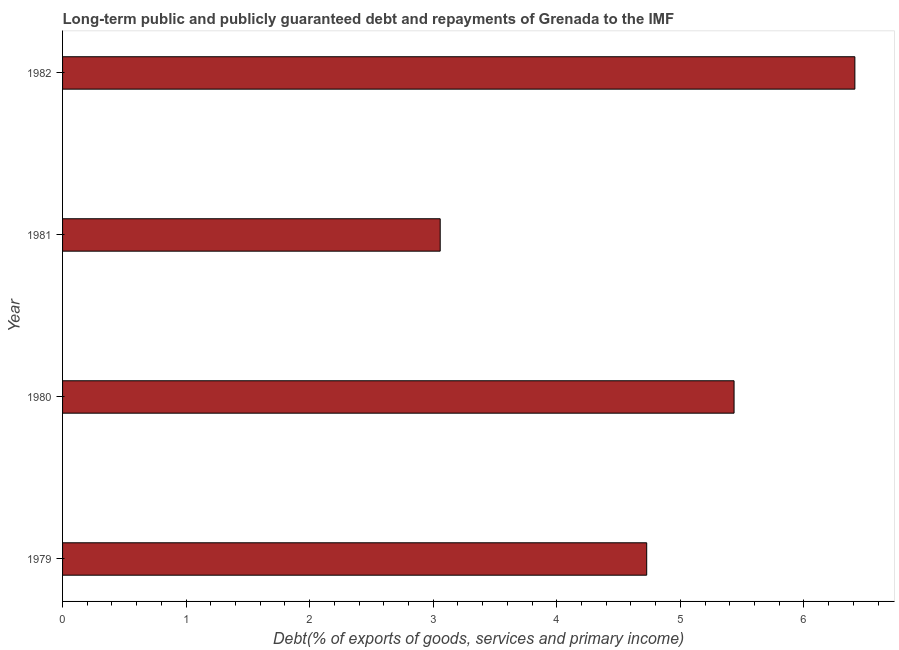Does the graph contain any zero values?
Your answer should be compact. No. What is the title of the graph?
Your answer should be very brief. Long-term public and publicly guaranteed debt and repayments of Grenada to the IMF. What is the label or title of the X-axis?
Keep it short and to the point. Debt(% of exports of goods, services and primary income). What is the debt service in 1980?
Offer a terse response. 5.43. Across all years, what is the maximum debt service?
Ensure brevity in your answer.  6.41. Across all years, what is the minimum debt service?
Give a very brief answer. 3.06. In which year was the debt service maximum?
Offer a very short reply. 1982. In which year was the debt service minimum?
Your response must be concise. 1981. What is the sum of the debt service?
Keep it short and to the point. 19.63. What is the difference between the debt service in 1981 and 1982?
Give a very brief answer. -3.36. What is the average debt service per year?
Make the answer very short. 4.91. What is the median debt service?
Your answer should be compact. 5.08. What is the ratio of the debt service in 1979 to that in 1980?
Provide a short and direct response. 0.87. Is the difference between the debt service in 1980 and 1982 greater than the difference between any two years?
Offer a terse response. No. What is the difference between the highest and the second highest debt service?
Provide a succinct answer. 0.98. What is the difference between the highest and the lowest debt service?
Your answer should be compact. 3.36. In how many years, is the debt service greater than the average debt service taken over all years?
Your answer should be compact. 2. What is the difference between two consecutive major ticks on the X-axis?
Provide a short and direct response. 1. What is the Debt(% of exports of goods, services and primary income) in 1979?
Provide a short and direct response. 4.73. What is the Debt(% of exports of goods, services and primary income) of 1980?
Provide a short and direct response. 5.43. What is the Debt(% of exports of goods, services and primary income) of 1981?
Ensure brevity in your answer.  3.06. What is the Debt(% of exports of goods, services and primary income) in 1982?
Give a very brief answer. 6.41. What is the difference between the Debt(% of exports of goods, services and primary income) in 1979 and 1980?
Give a very brief answer. -0.71. What is the difference between the Debt(% of exports of goods, services and primary income) in 1979 and 1981?
Your answer should be compact. 1.67. What is the difference between the Debt(% of exports of goods, services and primary income) in 1979 and 1982?
Your answer should be very brief. -1.68. What is the difference between the Debt(% of exports of goods, services and primary income) in 1980 and 1981?
Make the answer very short. 2.38. What is the difference between the Debt(% of exports of goods, services and primary income) in 1980 and 1982?
Provide a succinct answer. -0.98. What is the difference between the Debt(% of exports of goods, services and primary income) in 1981 and 1982?
Your answer should be very brief. -3.36. What is the ratio of the Debt(% of exports of goods, services and primary income) in 1979 to that in 1980?
Give a very brief answer. 0.87. What is the ratio of the Debt(% of exports of goods, services and primary income) in 1979 to that in 1981?
Ensure brevity in your answer.  1.55. What is the ratio of the Debt(% of exports of goods, services and primary income) in 1979 to that in 1982?
Keep it short and to the point. 0.74. What is the ratio of the Debt(% of exports of goods, services and primary income) in 1980 to that in 1981?
Your answer should be very brief. 1.78. What is the ratio of the Debt(% of exports of goods, services and primary income) in 1980 to that in 1982?
Make the answer very short. 0.85. What is the ratio of the Debt(% of exports of goods, services and primary income) in 1981 to that in 1982?
Ensure brevity in your answer.  0.48. 